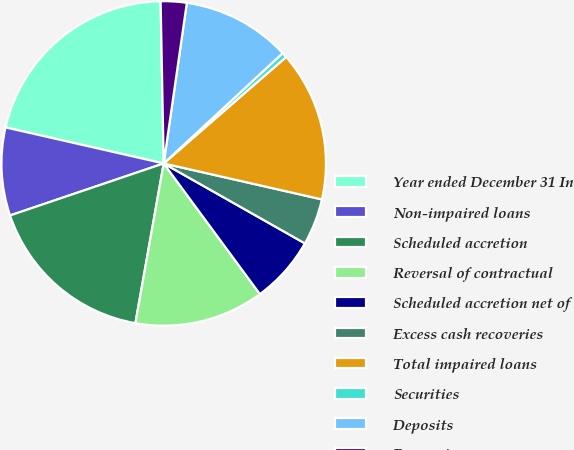<chart> <loc_0><loc_0><loc_500><loc_500><pie_chart><fcel>Year ended December 31 In<fcel>Non-impaired loans<fcel>Scheduled accretion<fcel>Reversal of contractual<fcel>Scheduled accretion net of<fcel>Excess cash recoveries<fcel>Total impaired loans<fcel>Securities<fcel>Deposits<fcel>Borrowings<nl><fcel>21.13%<fcel>8.76%<fcel>17.01%<fcel>12.89%<fcel>6.7%<fcel>4.64%<fcel>14.95%<fcel>0.51%<fcel>10.82%<fcel>2.58%<nl></chart> 